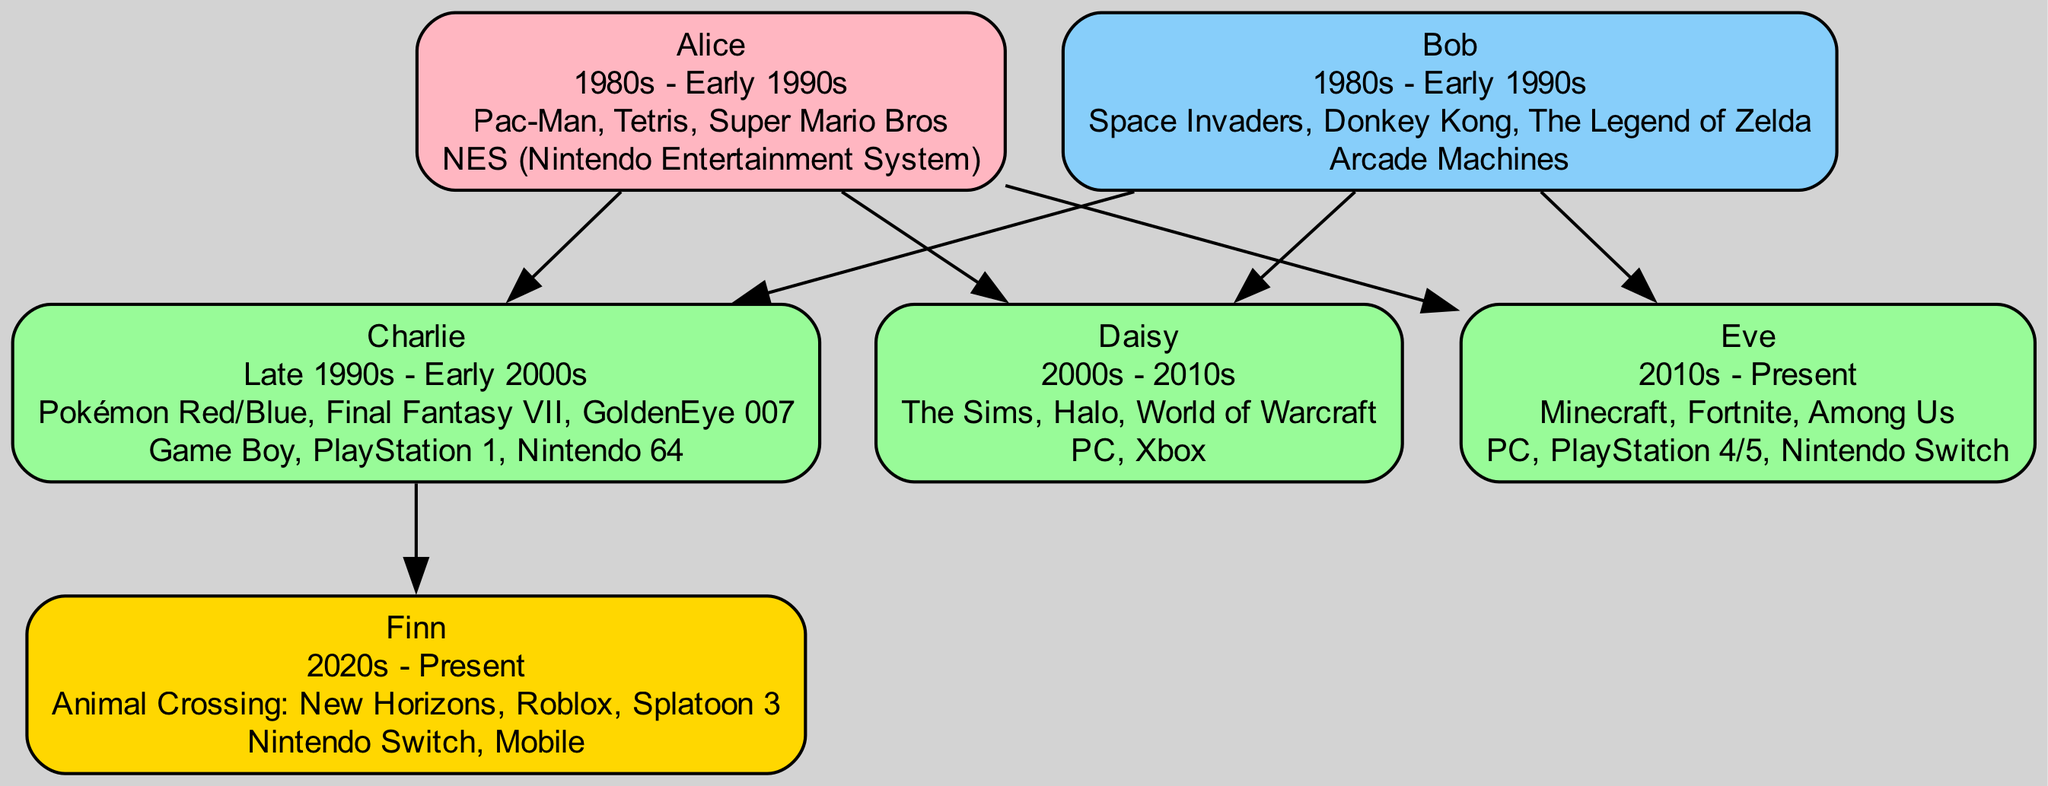What are Alice's preferred games? The node for Alice lists her preferred games: Pac-Man, Tetris, Super Mario Bros.
Answer: Pac-Man, Tetris, Super Mario Bros Which gaming device does Bob use? The node for Bob specifies his gaming device as Arcade Machines.
Answer: Arcade Machines How many children do Alice and Bob have? Counting the nodes connected to Alice and Bob, there are three children: Charlie, Daisy, and Eve.
Answer: 3 Who is the grandchild of Alice and Bob? The node connected to Charlie specifies their grandchild as Finn.
Answer: Finn What era does Eve's gaming preference belong to? The node for Eve states her era as 2010s - Present.
Answer: 2010s - Present Which game do Daisy and Eve both have in common? By reviewing their preferred games lists, the game Halo is only found in Daisy's list; Eve doesn't have it, thus there is no common game.
Answer: None What is the most recent gaming device mentioned in the tree? The latest gaming device mentioned in the diagram is the Nintendo Switch, listed under Finn, which represents the most recent generation of gaming devices in the family.
Answer: Nintendo Switch Which parent is associated with the game "The Legend of Zelda"? By checking the preferred games listed under Bob, "The Legend of Zelda" is mentioned, indicating he is the parent associated with it.
Answer: Bob How many preferred games does Charlie have? Charlie's node lists three preferred games: Pokémon Red/Blue, Final Fantasy VII, GoldenEye 007, which we can count to find the total.
Answer: 3 